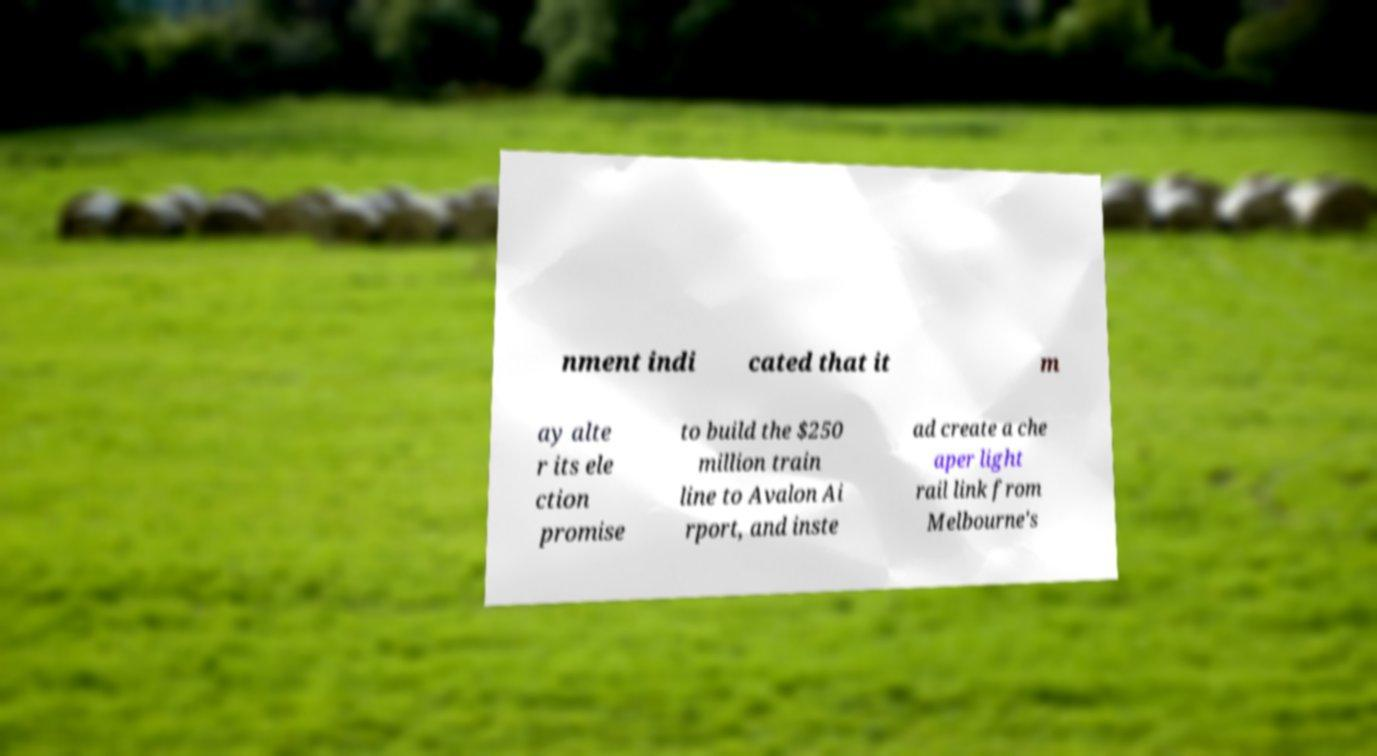For documentation purposes, I need the text within this image transcribed. Could you provide that? nment indi cated that it m ay alte r its ele ction promise to build the $250 million train line to Avalon Ai rport, and inste ad create a che aper light rail link from Melbourne's 